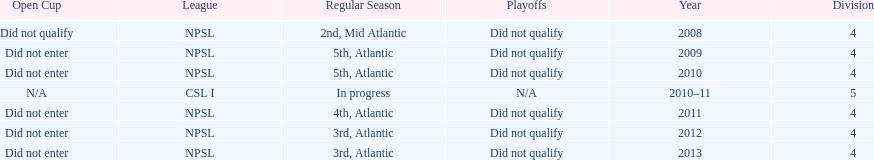What is the unique year that is referred to as n/a? 2010-11. 